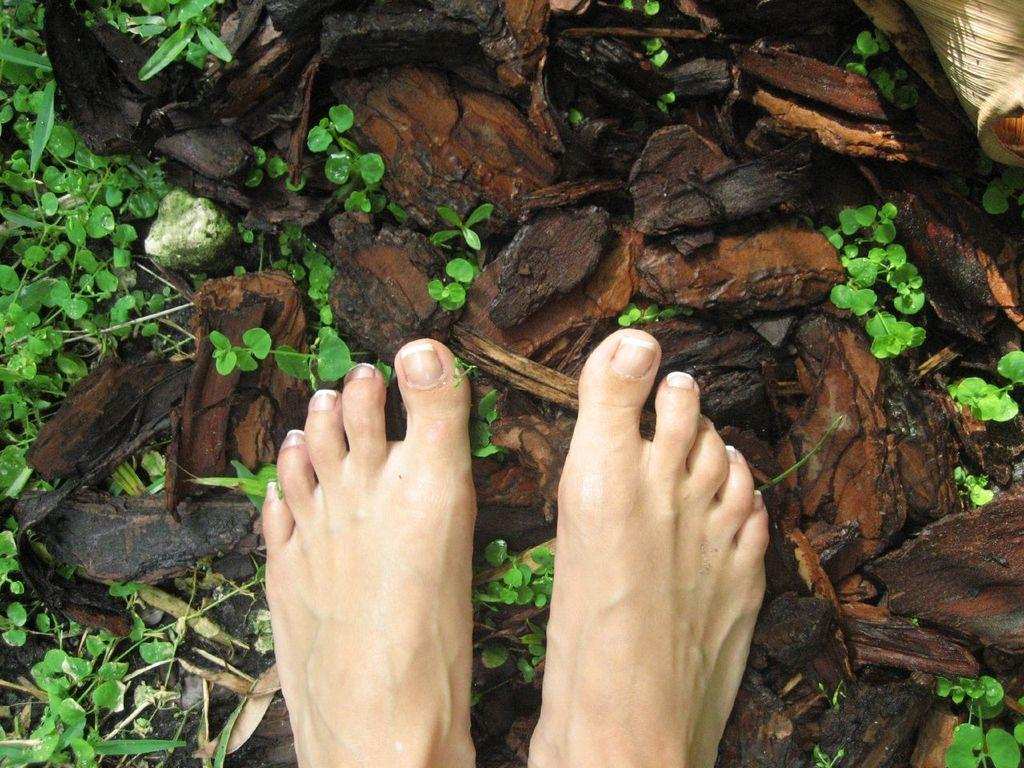What body parts are visible in the image? There are two human legs in the image. What type of objects are made of wood in the image? The wooden objects are brown and black in color. What type of living organisms are present in the image? There are plants in the image. What color are the plants in the image? The plants are green in color. What type of bubble can be seen in the image? There is no bubble present in the image. How does the breath of the person affect the plants in the image? There is no indication of the person's breath affecting the plants in the image. 